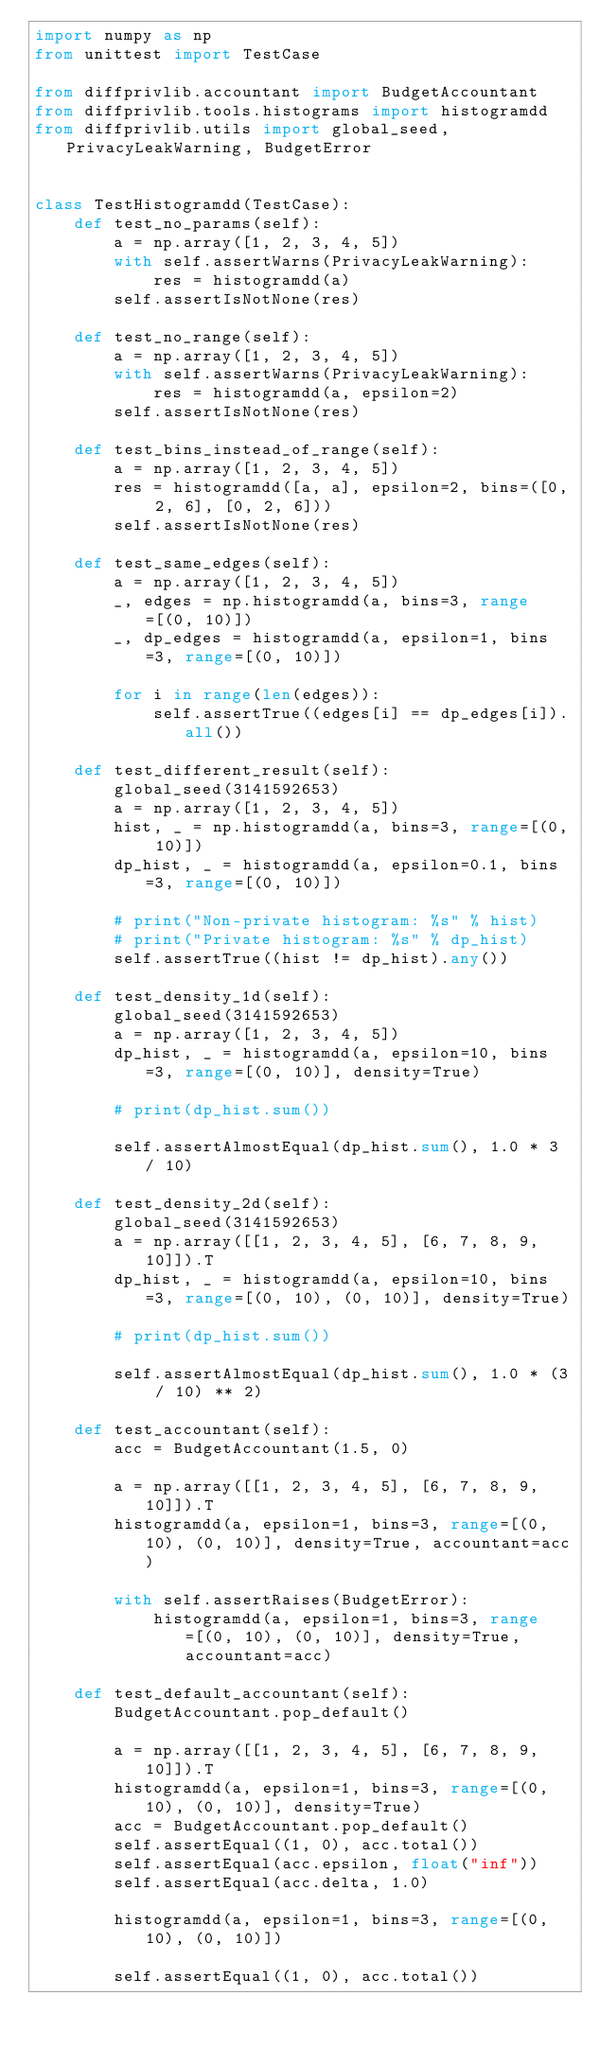Convert code to text. <code><loc_0><loc_0><loc_500><loc_500><_Python_>import numpy as np
from unittest import TestCase

from diffprivlib.accountant import BudgetAccountant
from diffprivlib.tools.histograms import histogramdd
from diffprivlib.utils import global_seed, PrivacyLeakWarning, BudgetError


class TestHistogramdd(TestCase):
    def test_no_params(self):
        a = np.array([1, 2, 3, 4, 5])
        with self.assertWarns(PrivacyLeakWarning):
            res = histogramdd(a)
        self.assertIsNotNone(res)

    def test_no_range(self):
        a = np.array([1, 2, 3, 4, 5])
        with self.assertWarns(PrivacyLeakWarning):
            res = histogramdd(a, epsilon=2)
        self.assertIsNotNone(res)

    def test_bins_instead_of_range(self):
        a = np.array([1, 2, 3, 4, 5])
        res = histogramdd([a, a], epsilon=2, bins=([0, 2, 6], [0, 2, 6]))
        self.assertIsNotNone(res)

    def test_same_edges(self):
        a = np.array([1, 2, 3, 4, 5])
        _, edges = np.histogramdd(a, bins=3, range=[(0, 10)])
        _, dp_edges = histogramdd(a, epsilon=1, bins=3, range=[(0, 10)])

        for i in range(len(edges)):
            self.assertTrue((edges[i] == dp_edges[i]).all())

    def test_different_result(self):
        global_seed(3141592653)
        a = np.array([1, 2, 3, 4, 5])
        hist, _ = np.histogramdd(a, bins=3, range=[(0, 10)])
        dp_hist, _ = histogramdd(a, epsilon=0.1, bins=3, range=[(0, 10)])

        # print("Non-private histogram: %s" % hist)
        # print("Private histogram: %s" % dp_hist)
        self.assertTrue((hist != dp_hist).any())

    def test_density_1d(self):
        global_seed(3141592653)
        a = np.array([1, 2, 3, 4, 5])
        dp_hist, _ = histogramdd(a, epsilon=10, bins=3, range=[(0, 10)], density=True)

        # print(dp_hist.sum())

        self.assertAlmostEqual(dp_hist.sum(), 1.0 * 3 / 10)

    def test_density_2d(self):
        global_seed(3141592653)
        a = np.array([[1, 2, 3, 4, 5], [6, 7, 8, 9, 10]]).T
        dp_hist, _ = histogramdd(a, epsilon=10, bins=3, range=[(0, 10), (0, 10)], density=True)

        # print(dp_hist.sum())

        self.assertAlmostEqual(dp_hist.sum(), 1.0 * (3 / 10) ** 2)

    def test_accountant(self):
        acc = BudgetAccountant(1.5, 0)

        a = np.array([[1, 2, 3, 4, 5], [6, 7, 8, 9, 10]]).T
        histogramdd(a, epsilon=1, bins=3, range=[(0, 10), (0, 10)], density=True, accountant=acc)

        with self.assertRaises(BudgetError):
            histogramdd(a, epsilon=1, bins=3, range=[(0, 10), (0, 10)], density=True, accountant=acc)

    def test_default_accountant(self):
        BudgetAccountant.pop_default()

        a = np.array([[1, 2, 3, 4, 5], [6, 7, 8, 9, 10]]).T
        histogramdd(a, epsilon=1, bins=3, range=[(0, 10), (0, 10)], density=True)
        acc = BudgetAccountant.pop_default()
        self.assertEqual((1, 0), acc.total())
        self.assertEqual(acc.epsilon, float("inf"))
        self.assertEqual(acc.delta, 1.0)

        histogramdd(a, epsilon=1, bins=3, range=[(0, 10), (0, 10)])

        self.assertEqual((1, 0), acc.total())
</code> 